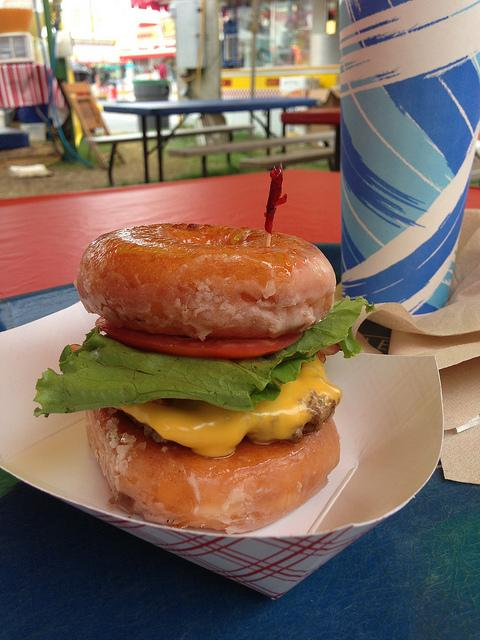What is the most unhealthy part of this cheeseburger? donuts 